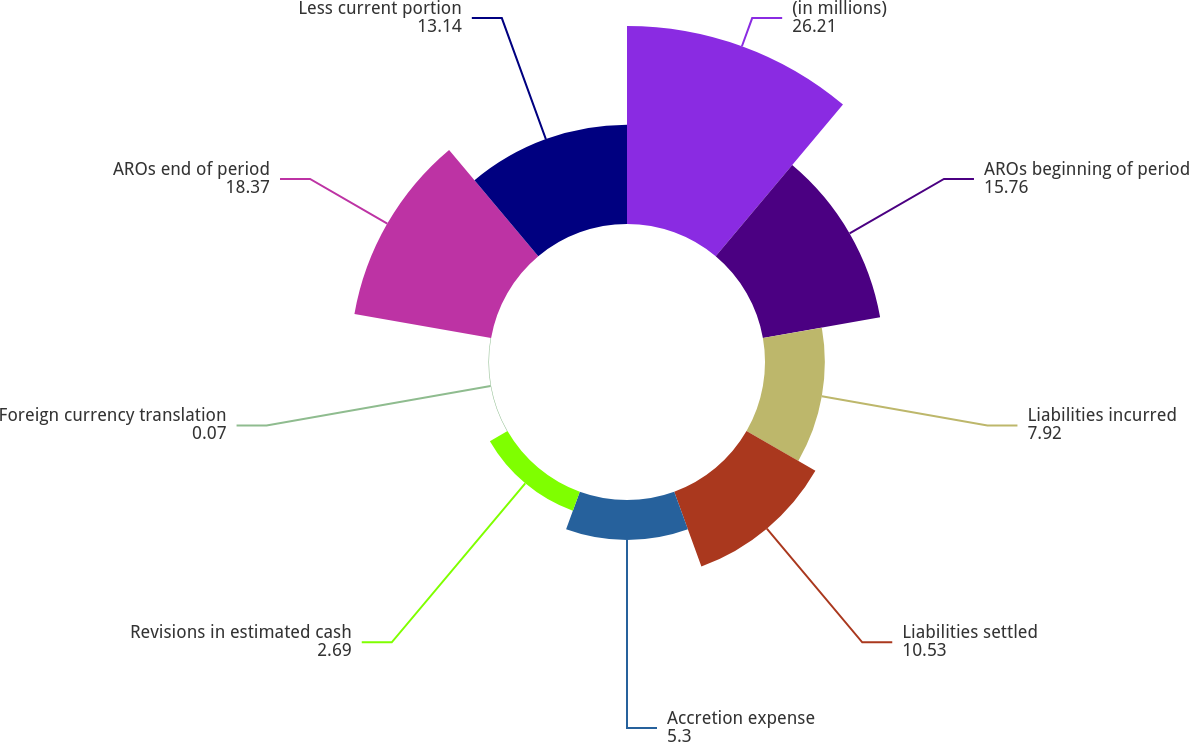Convert chart. <chart><loc_0><loc_0><loc_500><loc_500><pie_chart><fcel>(in millions)<fcel>AROs beginning of period<fcel>Liabilities incurred<fcel>Liabilities settled<fcel>Accretion expense<fcel>Revisions in estimated cash<fcel>Foreign currency translation<fcel>AROs end of period<fcel>Less current portion<nl><fcel>26.21%<fcel>15.76%<fcel>7.92%<fcel>10.53%<fcel>5.3%<fcel>2.69%<fcel>0.07%<fcel>18.37%<fcel>13.14%<nl></chart> 